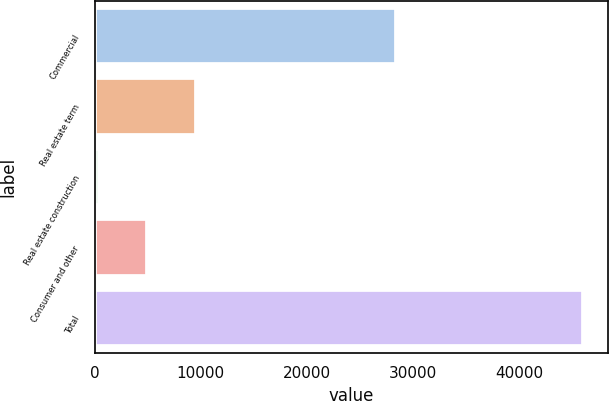<chart> <loc_0><loc_0><loc_500><loc_500><bar_chart><fcel>Commercial<fcel>Real estate term<fcel>Real estate construction<fcel>Consumer and other<fcel>Total<nl><fcel>28417<fcel>9499.2<fcel>374<fcel>4936.6<fcel>46000<nl></chart> 